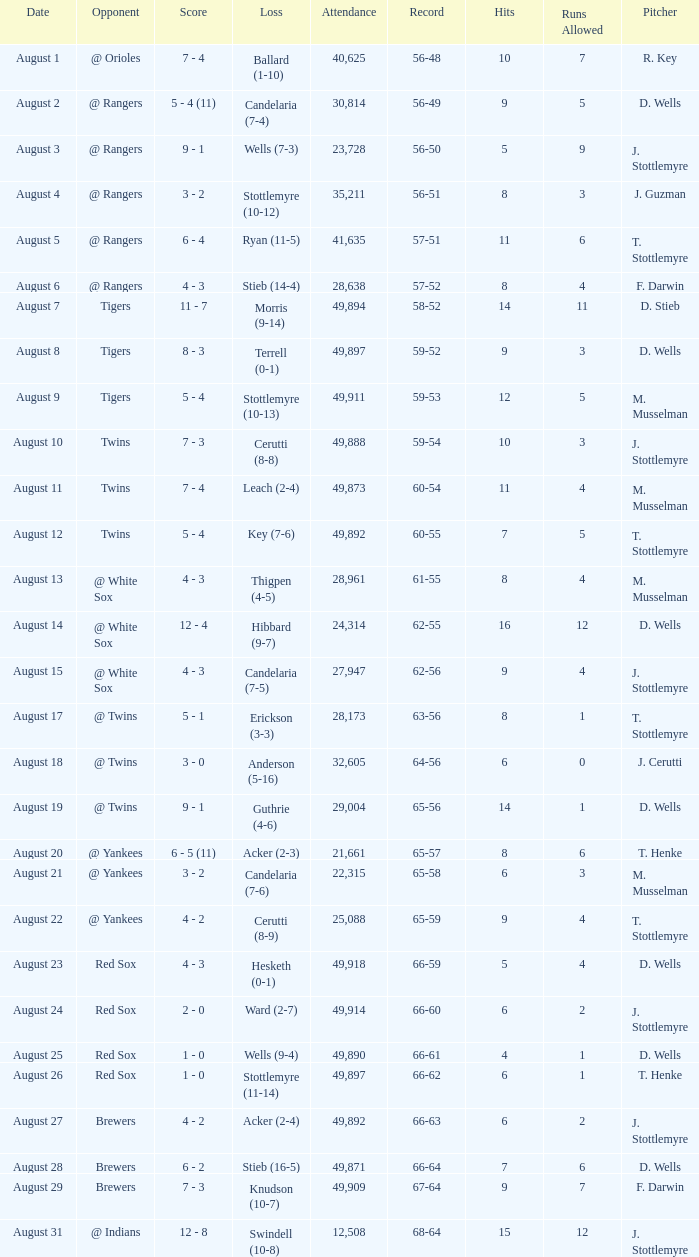What was the Attendance high on August 28? 49871.0. 